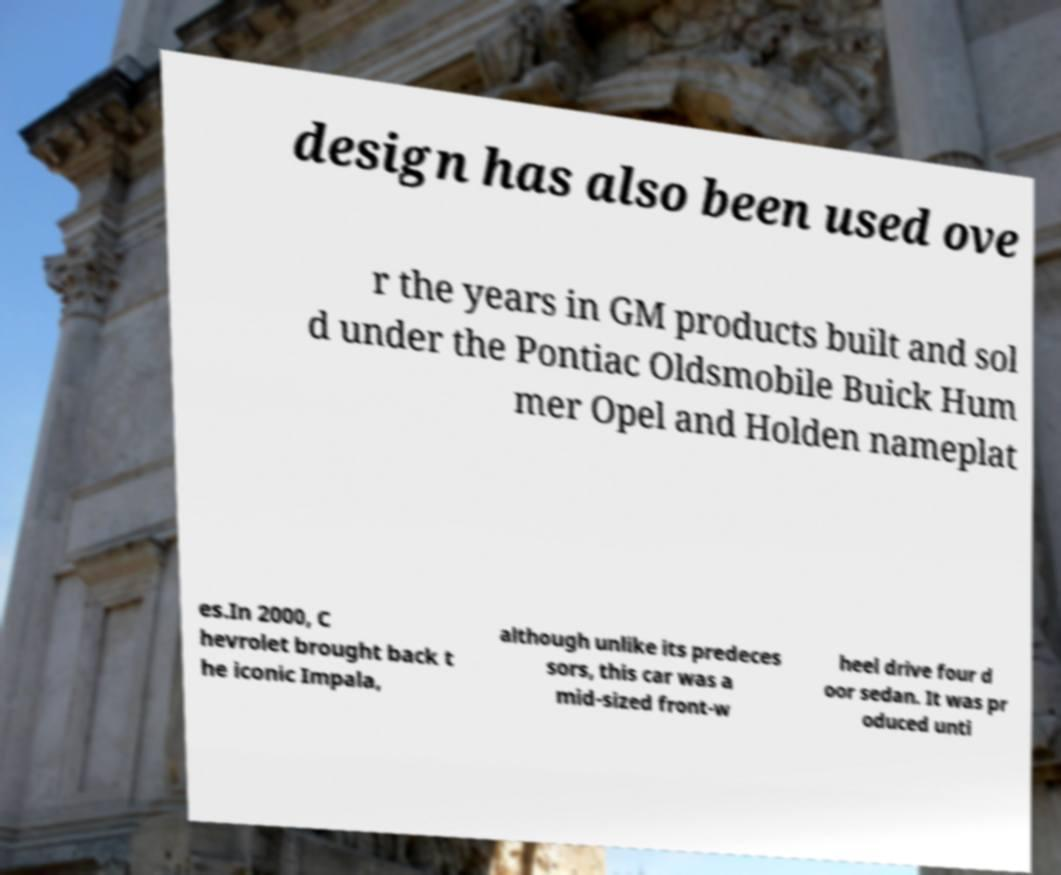I need the written content from this picture converted into text. Can you do that? design has also been used ove r the years in GM products built and sol d under the Pontiac Oldsmobile Buick Hum mer Opel and Holden nameplat es.In 2000, C hevrolet brought back t he iconic Impala, although unlike its predeces sors, this car was a mid-sized front-w heel drive four d oor sedan. It was pr oduced unti 